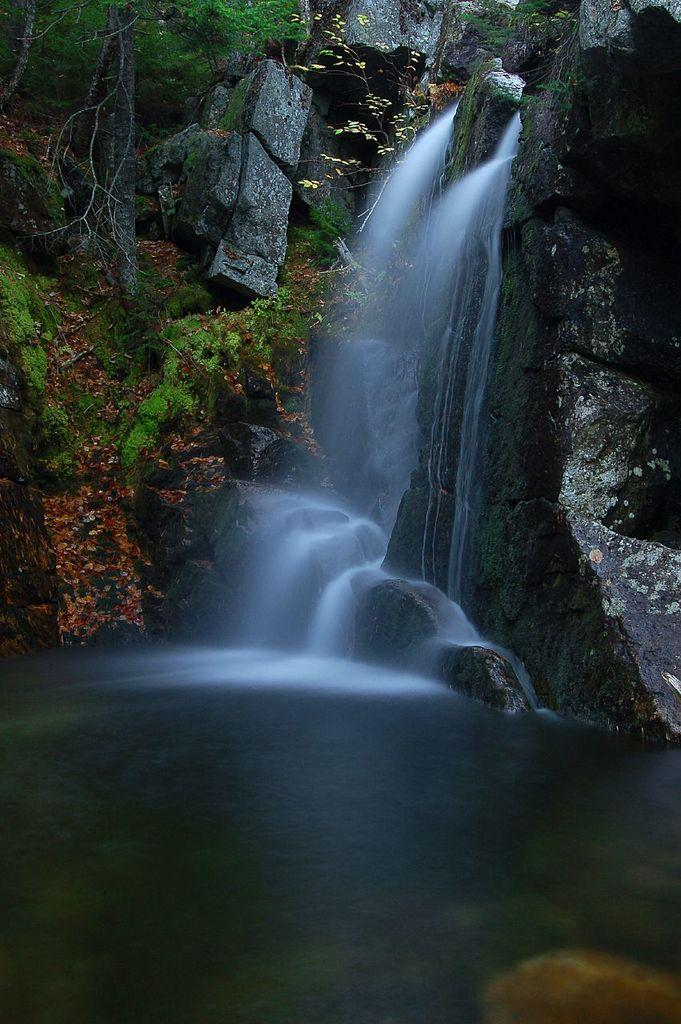What type of natural features can be seen in the image? There are trees and a waterfall in the image. What is the color of the rock mountain in the image? The rock mountain in the image is black. Can you see a needle sticking out of the trees in the image? No, there is no needle present in the image. 